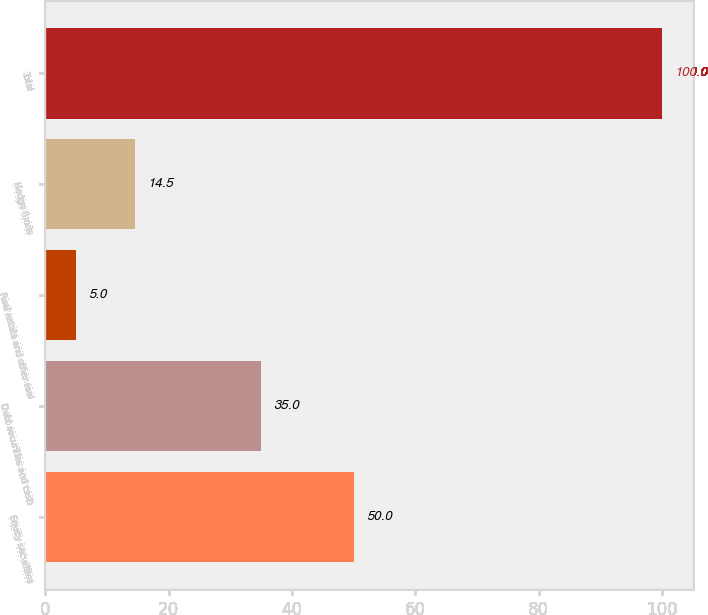<chart> <loc_0><loc_0><loc_500><loc_500><bar_chart><fcel>Equity securities<fcel>Debt securities and cash<fcel>Real estate and other real<fcel>Hedge funds<fcel>Total<nl><fcel>50<fcel>35<fcel>5<fcel>14.5<fcel>100<nl></chart> 